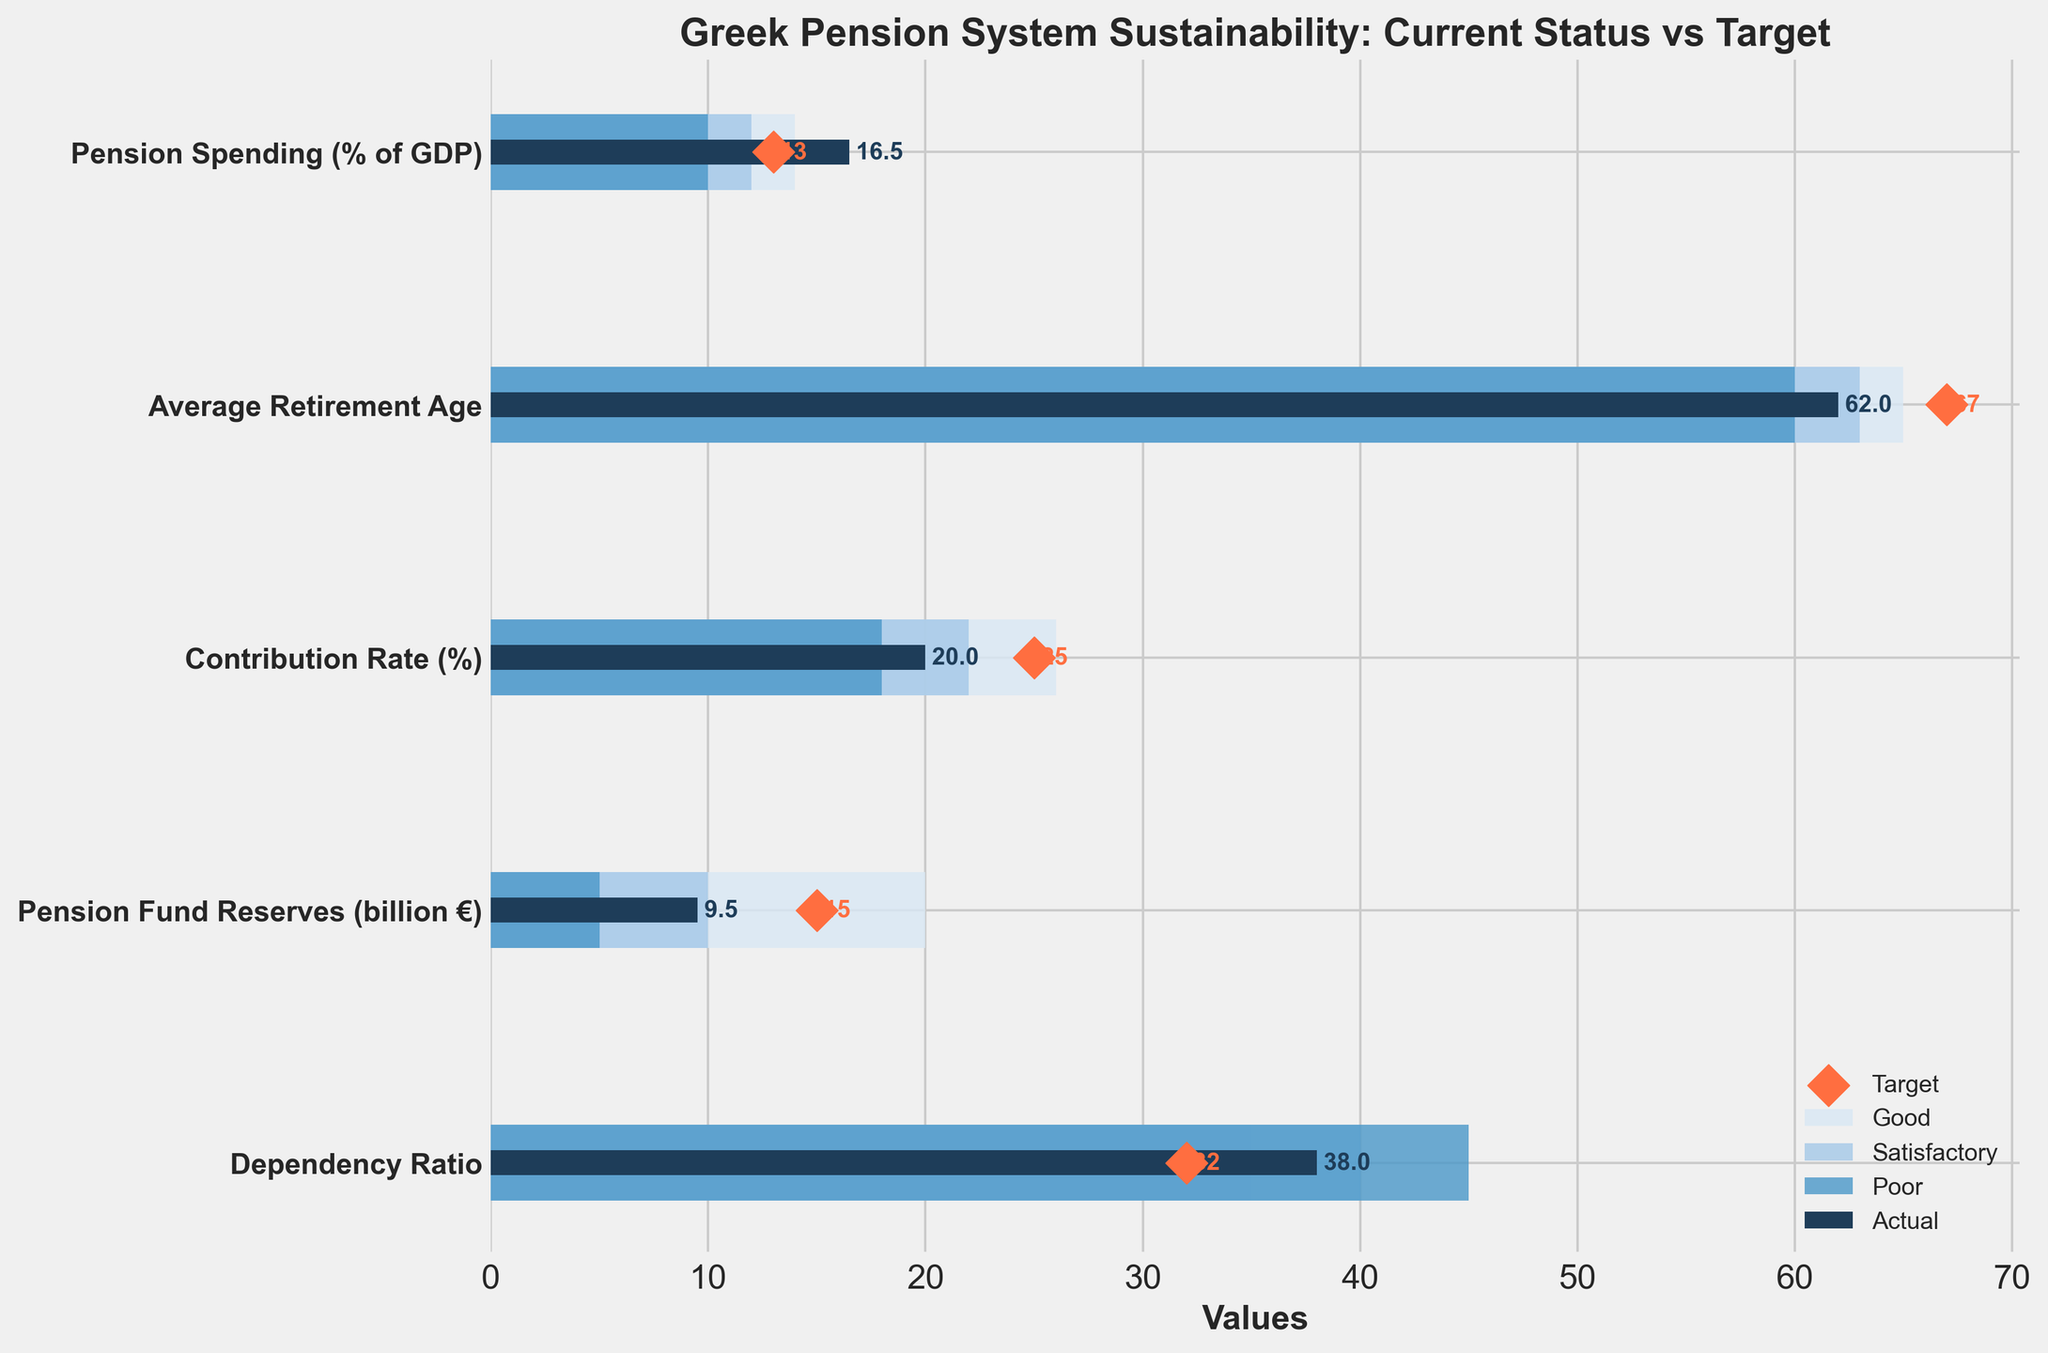what is the actual pension spending percentage of GDP? The bar labeled "Pension Spending (% of GDP)" represents the actual percentage of GDP spent on pensions. The value shown on the dark bar is 16.5%.
Answer: 16.5% Which metric has the largest difference between actual and target values? To find the largest difference, subtract the target value from the actual value for each metric. Pension Spending: 16.5 - 13 = 3.5, Retirement Age: 67 - 62 = 5, Contribution Rate: 25 - 20 = 5, Pension Fund Reserves: 15 - 9.5 = 5.5, Dependency Ratio: 38 - 32 = 6. Therefore, the largest difference is seen in the Dependency Ratio.
Answer: Dependency Ratio What range is marked as "Good" for the Average Retirement Age? The bar labeled "Average Retirement Age" shows three shades indicating ranges. The lightest shade, marked as "Good," covers the range from 63 to 65.
Answer: 63 to 65 Is the current contribution rate higher or lower than the target contribution rate? Look at the "Contribution Rate (%)" metric. The actual (dark bar) value is 20%, and the target (red diamond) value is 25%. The actual value is lower than the target value.
Answer: Lower Which metrics fall within the "Satisfactory" range for the actual values? Check where the dark bars (actual values) fall within the light blue shades (Satisfactory range). "Pension Spending" (16.5%) and "Pension Fund Reserves" (9.5 billion €) both fall within their respective Satisfactory ranges of 10-12% and 10-20 billion €, respectively.
Answer: Pension Spending, Pension Fund Reserves What is the difference between the target and the actual value of Pension Fund Reserves? The actual value for Pension Fund Reserves is 9.5 billion €, and the target is 15 billion €. Subtract the actual value from the target: 15 - 9.5 = 5.5 billion €.
Answer: 5.5 billion € How many metrics have their actual values in the "Poor" range? Check where the dark bars (actual values) fall within the dark blue shades (Poor range). "Pension Spending" (16.5%) and "Average Retirement Age" (62 years) fall within their respective Poor ranges of 10-12% and 60-63 years, respectively.
Answer: Two metrics By how much does the actual dependency ratio exceed the target ratio? The actual dependency ratio is 38, while the target is 32. Subtract the target value from the actual value: 38 - 32 = 6.
Answer: 6 